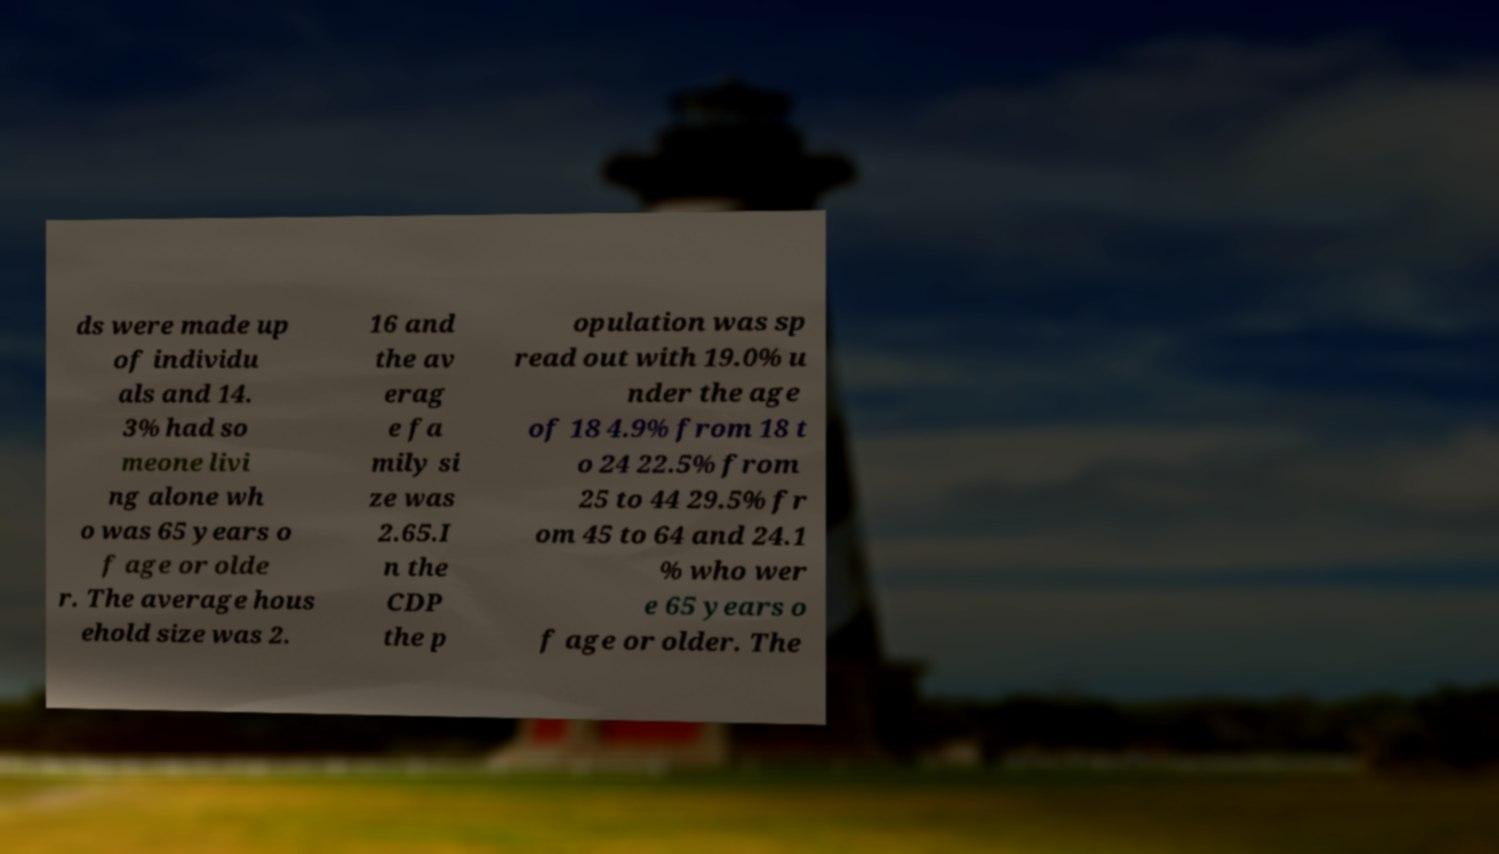Please identify and transcribe the text found in this image. ds were made up of individu als and 14. 3% had so meone livi ng alone wh o was 65 years o f age or olde r. The average hous ehold size was 2. 16 and the av erag e fa mily si ze was 2.65.I n the CDP the p opulation was sp read out with 19.0% u nder the age of 18 4.9% from 18 t o 24 22.5% from 25 to 44 29.5% fr om 45 to 64 and 24.1 % who wer e 65 years o f age or older. The 